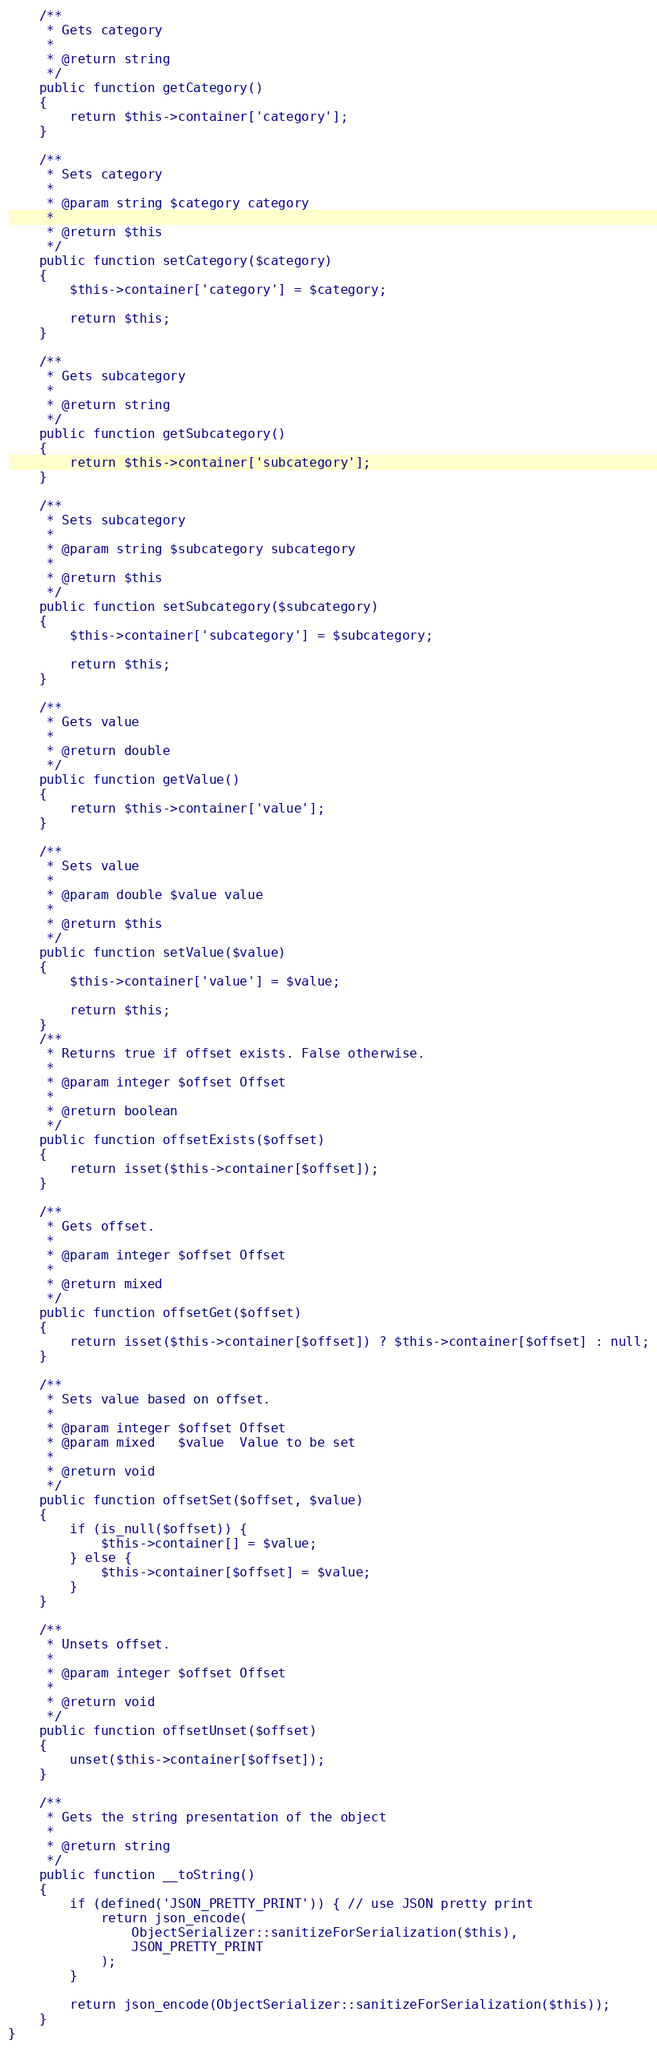<code> <loc_0><loc_0><loc_500><loc_500><_PHP_>
    /**
     * Gets category
     *
     * @return string
     */
    public function getCategory()
    {
        return $this->container['category'];
    }

    /**
     * Sets category
     *
     * @param string $category category
     *
     * @return $this
     */
    public function setCategory($category)
    {
        $this->container['category'] = $category;

        return $this;
    }

    /**
     * Gets subcategory
     *
     * @return string
     */
    public function getSubcategory()
    {
        return $this->container['subcategory'];
    }

    /**
     * Sets subcategory
     *
     * @param string $subcategory subcategory
     *
     * @return $this
     */
    public function setSubcategory($subcategory)
    {
        $this->container['subcategory'] = $subcategory;

        return $this;
    }

    /**
     * Gets value
     *
     * @return double
     */
    public function getValue()
    {
        return $this->container['value'];
    }

    /**
     * Sets value
     *
     * @param double $value value
     *
     * @return $this
     */
    public function setValue($value)
    {
        $this->container['value'] = $value;

        return $this;
    }
    /**
     * Returns true if offset exists. False otherwise.
     *
     * @param integer $offset Offset
     *
     * @return boolean
     */
    public function offsetExists($offset)
    {
        return isset($this->container[$offset]);
    }

    /**
     * Gets offset.
     *
     * @param integer $offset Offset
     *
     * @return mixed
     */
    public function offsetGet($offset)
    {
        return isset($this->container[$offset]) ? $this->container[$offset] : null;
    }

    /**
     * Sets value based on offset.
     *
     * @param integer $offset Offset
     * @param mixed   $value  Value to be set
     *
     * @return void
     */
    public function offsetSet($offset, $value)
    {
        if (is_null($offset)) {
            $this->container[] = $value;
        } else {
            $this->container[$offset] = $value;
        }
    }

    /**
     * Unsets offset.
     *
     * @param integer $offset Offset
     *
     * @return void
     */
    public function offsetUnset($offset)
    {
        unset($this->container[$offset]);
    }

    /**
     * Gets the string presentation of the object
     *
     * @return string
     */
    public function __toString()
    {
        if (defined('JSON_PRETTY_PRINT')) { // use JSON pretty print
            return json_encode(
                ObjectSerializer::sanitizeForSerialization($this),
                JSON_PRETTY_PRINT
            );
        }

        return json_encode(ObjectSerializer::sanitizeForSerialization($this));
    }
}


</code> 